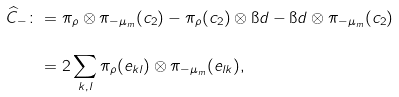<formula> <loc_0><loc_0><loc_500><loc_500>\widehat { C } _ { - } \colon & = \pi _ { \rho } \otimes \pi _ { - \mu _ { m } } ( c _ { 2 } ) - \pi _ { \rho } ( c _ { 2 } ) \otimes \i d - \i d \otimes \pi _ { - \mu _ { m } } ( c _ { 2 } ) \\ & = 2 \sum _ { k , l } \pi _ { \rho } ( e _ { k l } ) \otimes \pi _ { - \mu _ { m } } ( e _ { l k } ) ,</formula> 